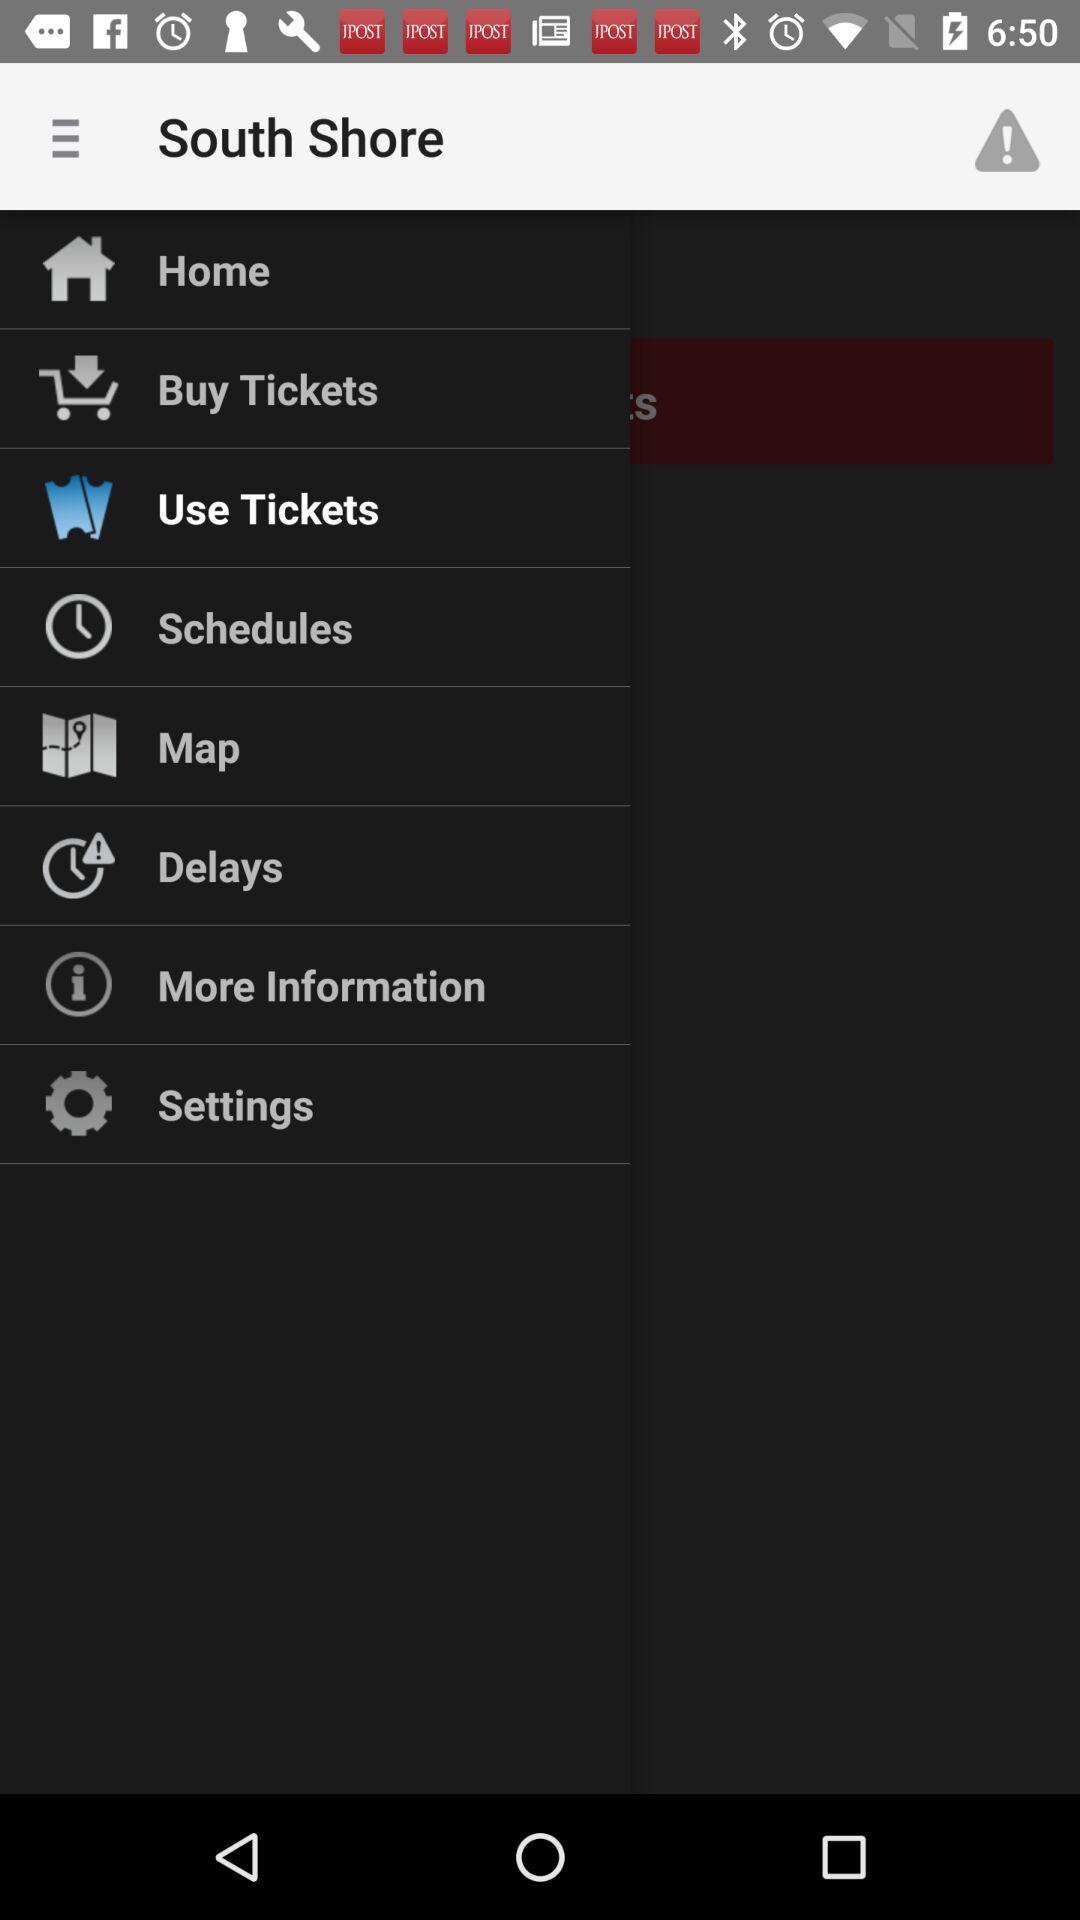What is the name of the application? The name of the application is "South Shore". 